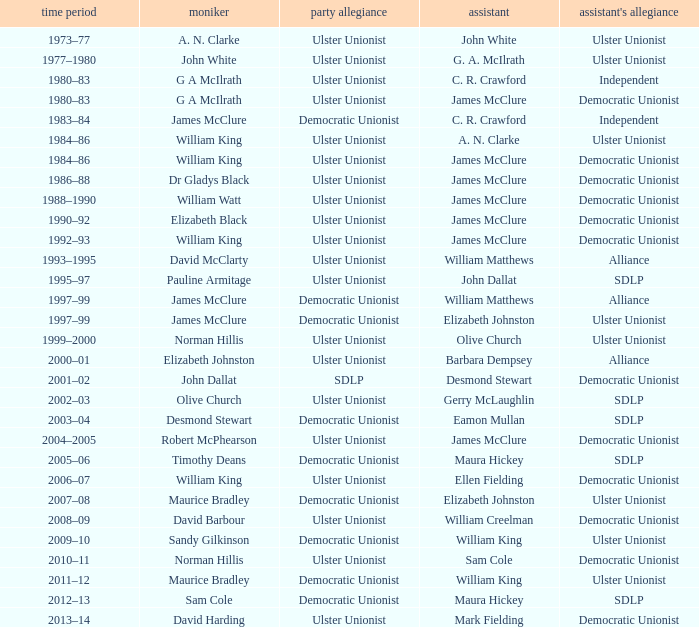What is the name of the Deputy when the Name was elizabeth black? James McClure. 